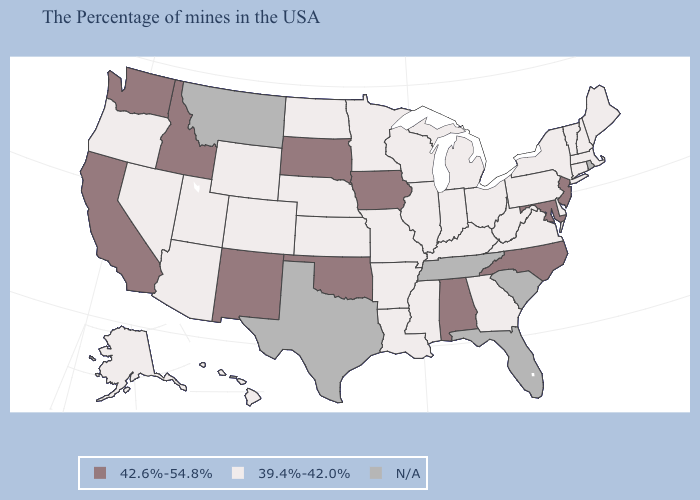What is the value of Nebraska?
Quick response, please. 39.4%-42.0%. Among the states that border Washington , which have the highest value?
Keep it brief. Idaho. Which states have the lowest value in the Northeast?
Write a very short answer. Maine, Massachusetts, New Hampshire, Vermont, Connecticut, New York, Pennsylvania. Among the states that border North Dakota , which have the lowest value?
Quick response, please. Minnesota. Name the states that have a value in the range N/A?
Concise answer only. Rhode Island, South Carolina, Florida, Tennessee, Texas, Montana. What is the value of Tennessee?
Be succinct. N/A. Name the states that have a value in the range 39.4%-42.0%?
Be succinct. Maine, Massachusetts, New Hampshire, Vermont, Connecticut, New York, Delaware, Pennsylvania, Virginia, West Virginia, Ohio, Georgia, Michigan, Kentucky, Indiana, Wisconsin, Illinois, Mississippi, Louisiana, Missouri, Arkansas, Minnesota, Kansas, Nebraska, North Dakota, Wyoming, Colorado, Utah, Arizona, Nevada, Oregon, Alaska, Hawaii. Name the states that have a value in the range 42.6%-54.8%?
Keep it brief. New Jersey, Maryland, North Carolina, Alabama, Iowa, Oklahoma, South Dakota, New Mexico, Idaho, California, Washington. Among the states that border Kentucky , which have the lowest value?
Keep it brief. Virginia, West Virginia, Ohio, Indiana, Illinois, Missouri. Which states have the lowest value in the USA?
Write a very short answer. Maine, Massachusetts, New Hampshire, Vermont, Connecticut, New York, Delaware, Pennsylvania, Virginia, West Virginia, Ohio, Georgia, Michigan, Kentucky, Indiana, Wisconsin, Illinois, Mississippi, Louisiana, Missouri, Arkansas, Minnesota, Kansas, Nebraska, North Dakota, Wyoming, Colorado, Utah, Arizona, Nevada, Oregon, Alaska, Hawaii. What is the lowest value in the USA?
Keep it brief. 39.4%-42.0%. What is the value of Indiana?
Answer briefly. 39.4%-42.0%. What is the lowest value in the South?
Be succinct. 39.4%-42.0%. 